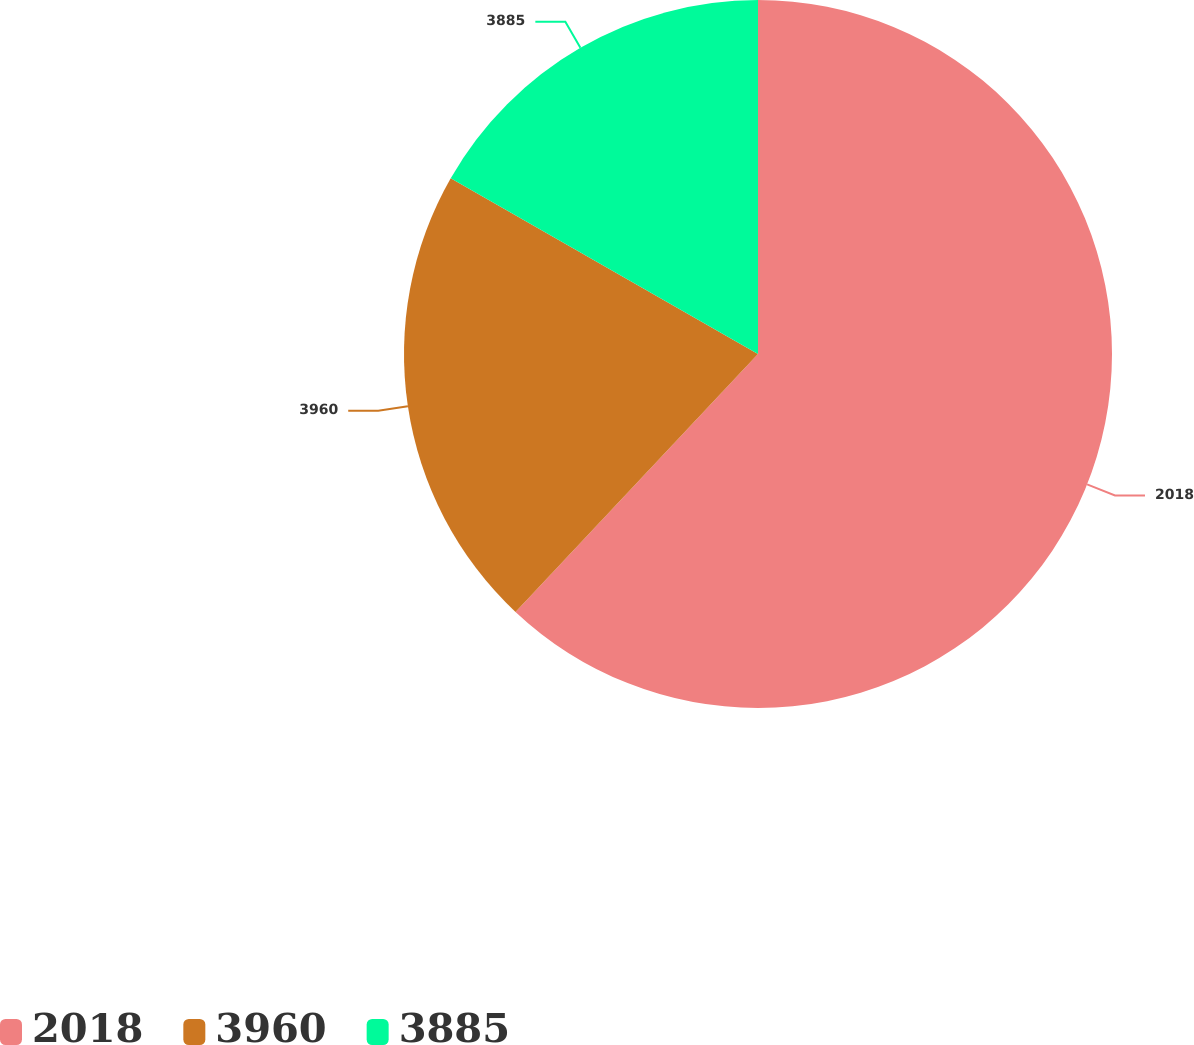Convert chart. <chart><loc_0><loc_0><loc_500><loc_500><pie_chart><fcel>2018<fcel>3960<fcel>3885<nl><fcel>62.01%<fcel>21.26%<fcel>16.73%<nl></chart> 